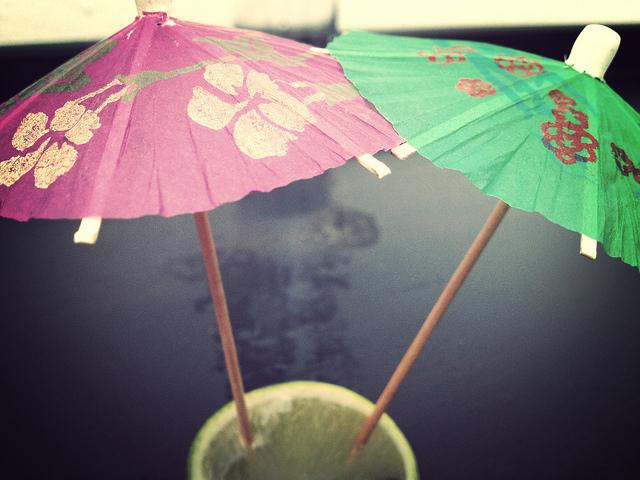What are the umbrellas made of?
Answer briefly. Paper. What kind of beverage would these umbrellas be found in?
Give a very brief answer. Alcoholic. Are the two umbrellas the same color?
Be succinct. No. 